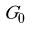<formula> <loc_0><loc_0><loc_500><loc_500>\tilde { G _ { 0 } }</formula> 